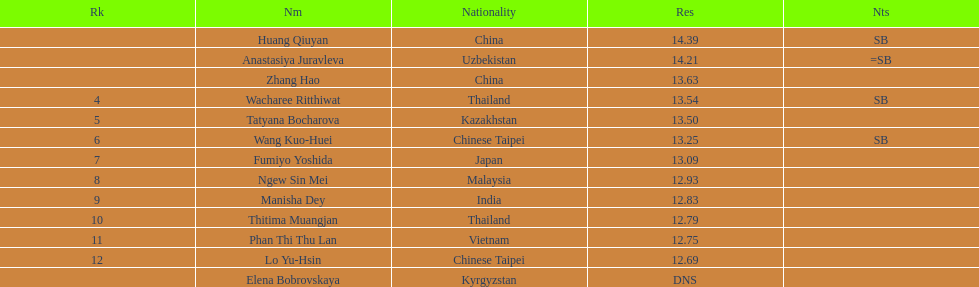What is the dissimilarity between huang qiuyan's achievement and fumiyo yoshida's achievement? 1.3. 